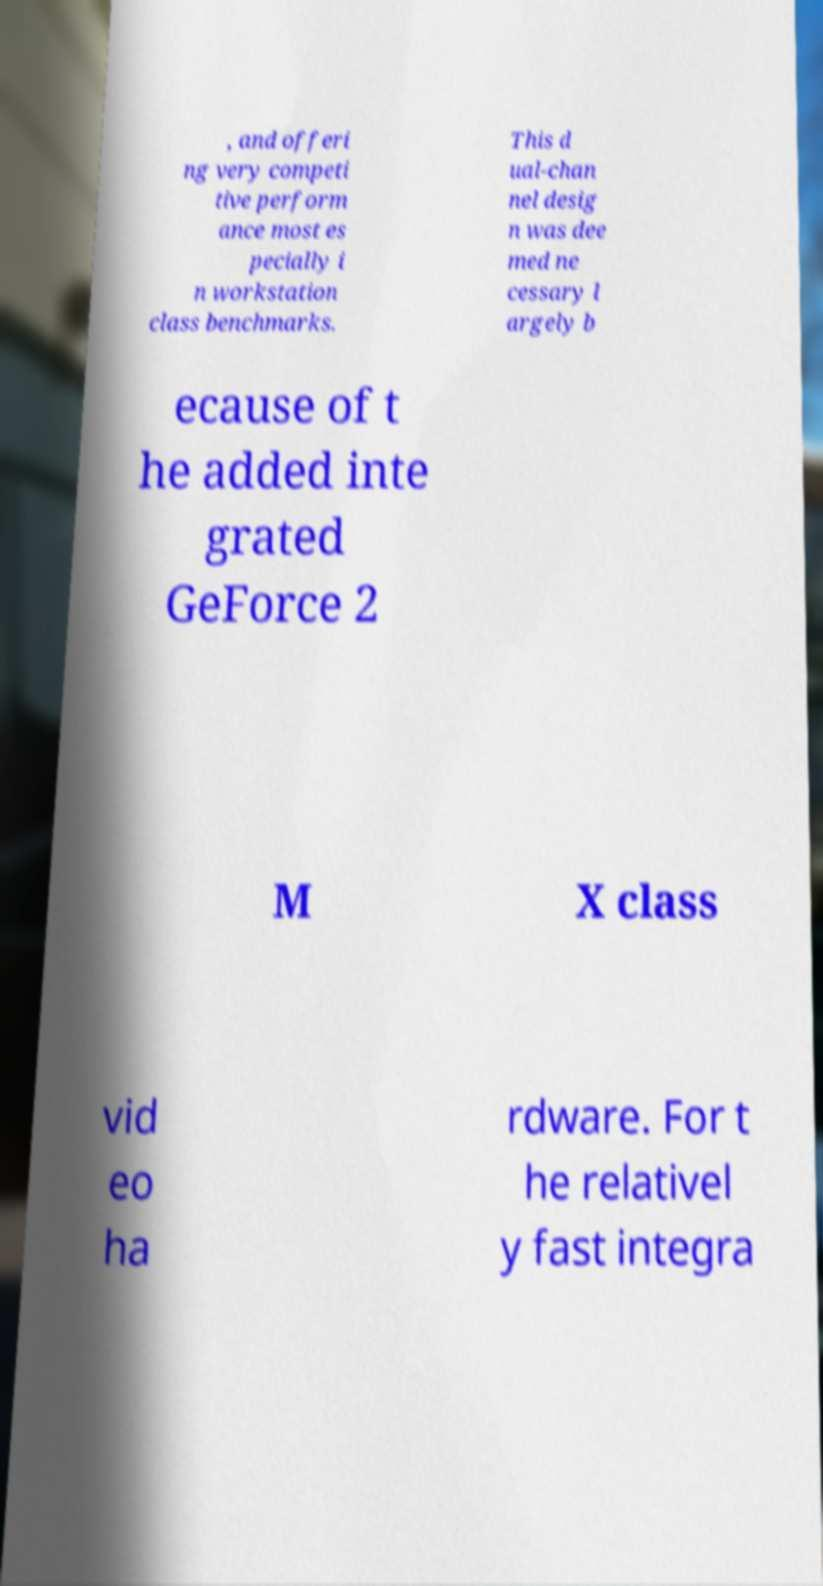Can you read and provide the text displayed in the image?This photo seems to have some interesting text. Can you extract and type it out for me? , and offeri ng very competi tive perform ance most es pecially i n workstation class benchmarks. This d ual-chan nel desig n was dee med ne cessary l argely b ecause of t he added inte grated GeForce 2 M X class vid eo ha rdware. For t he relativel y fast integra 